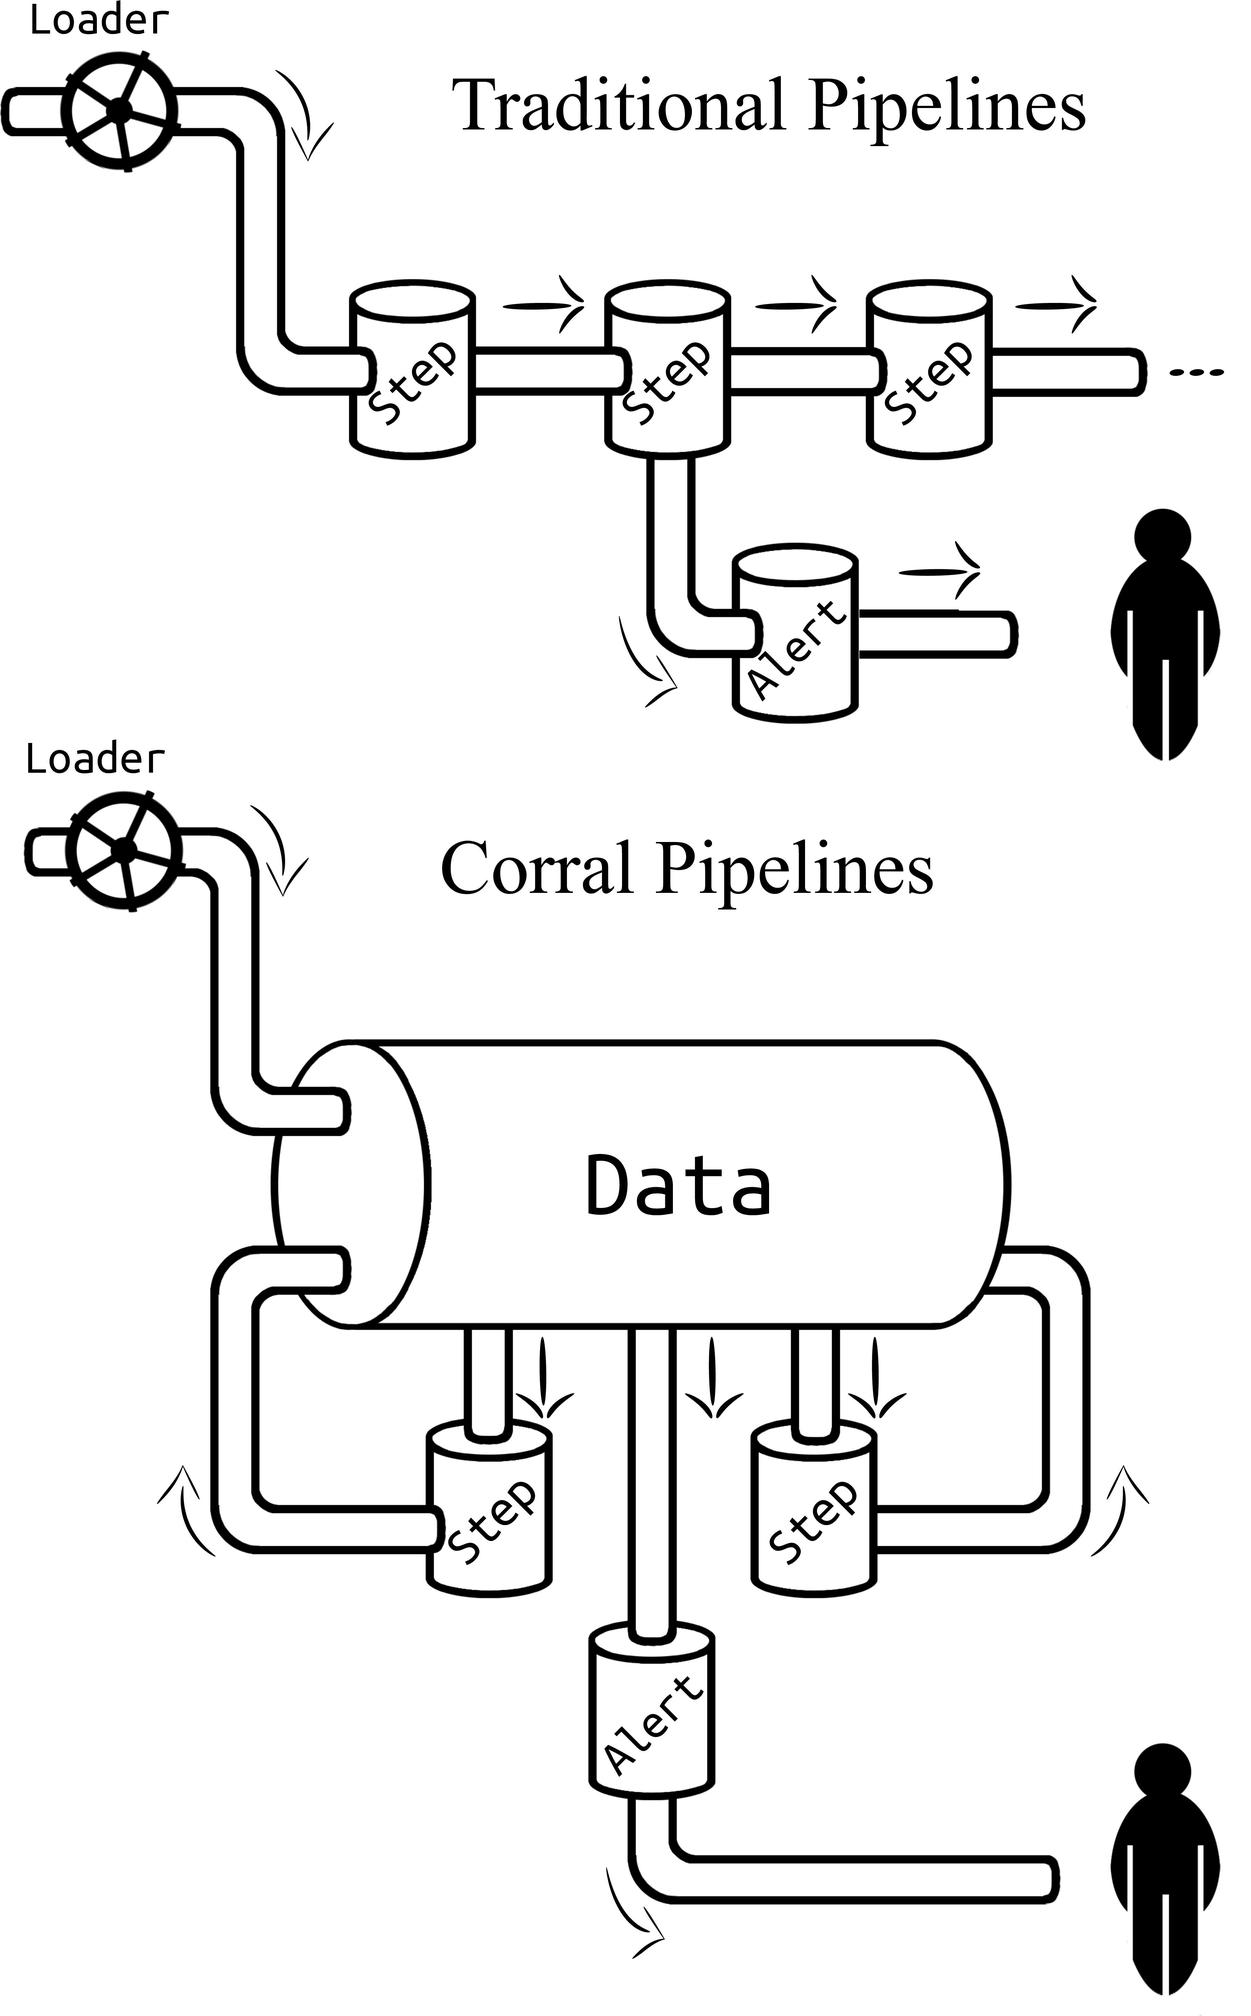Please describe the differences between the 'Traditional Pipelines' and the 'Corral Pipelines' shown in the image. The image depicts two different data pipeline architectures. In the 'Traditional Pipelines', we see a linear sequence of steps where data passes through each stage one by one, with an 'Alert' branching out from various steps. Conversely, the 'Corral Pipelines' show a more centralized approach, where all processes are encapsulated within a larger 'Data' rectangle, suggesting integrated processing and management of data. Here also, 'Alert' components are attached to certain stages. The key difference seems to be the centralized versus linear management of the data as it flows through the system, with the traditional approach indicating a step-by-step process and the corral indicating a more collective and networked operation. 